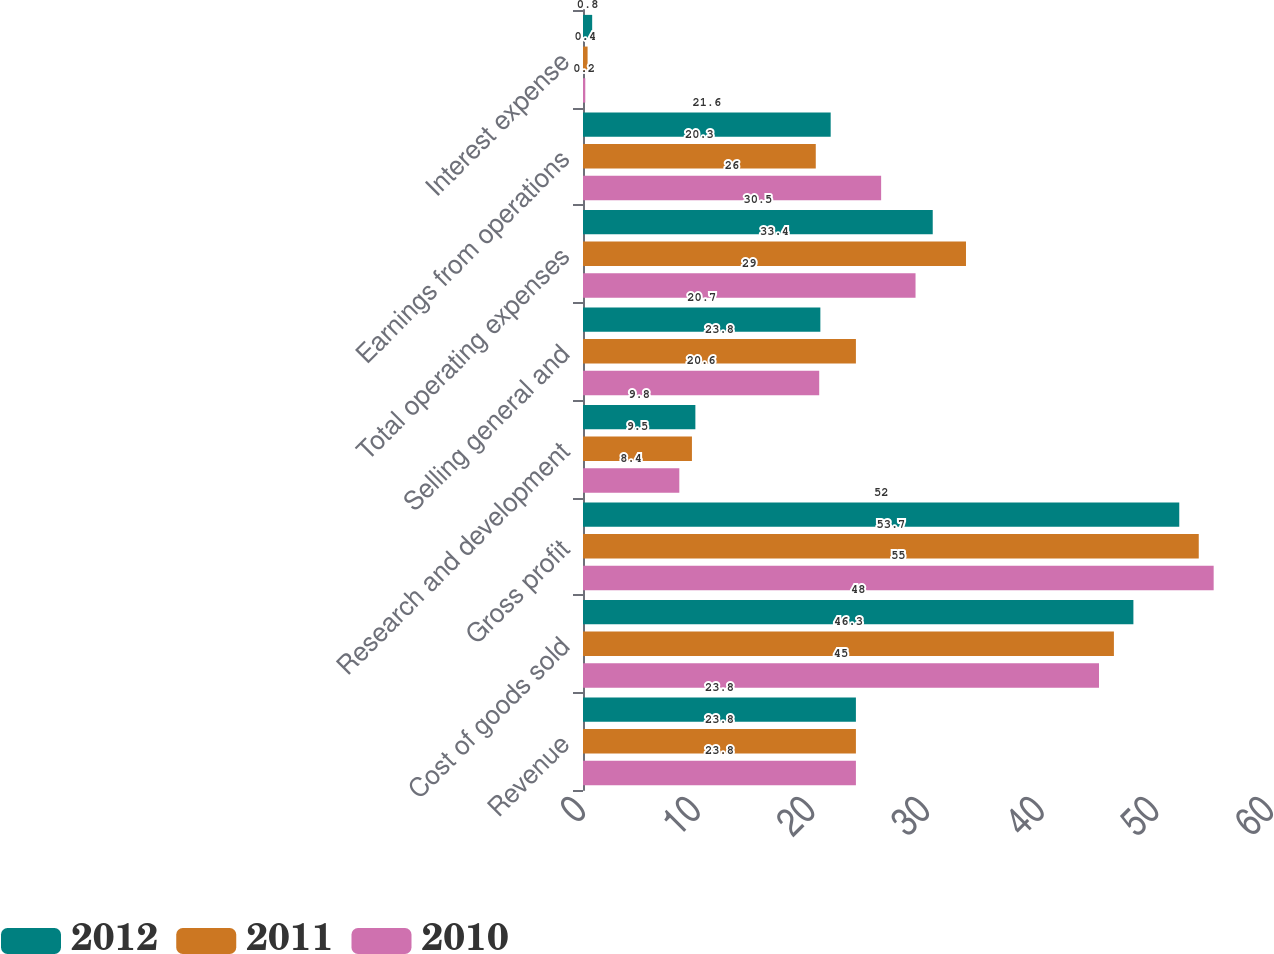<chart> <loc_0><loc_0><loc_500><loc_500><stacked_bar_chart><ecel><fcel>Revenue<fcel>Cost of goods sold<fcel>Gross profit<fcel>Research and development<fcel>Selling general and<fcel>Total operating expenses<fcel>Earnings from operations<fcel>Interest expense<nl><fcel>2012<fcel>23.8<fcel>48<fcel>52<fcel>9.8<fcel>20.7<fcel>30.5<fcel>21.6<fcel>0.8<nl><fcel>2011<fcel>23.8<fcel>46.3<fcel>53.7<fcel>9.5<fcel>23.8<fcel>33.4<fcel>20.3<fcel>0.4<nl><fcel>2010<fcel>23.8<fcel>45<fcel>55<fcel>8.4<fcel>20.6<fcel>29<fcel>26<fcel>0.2<nl></chart> 